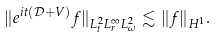<formula> <loc_0><loc_0><loc_500><loc_500>\| e ^ { i t ( \mathcal { D } + V ) } f \| _ { L ^ { 2 } _ { t } L ^ { \infty } _ { r } L ^ { 2 } _ { \omega } } \lesssim \| f \| _ { H ^ { 1 } } .</formula> 